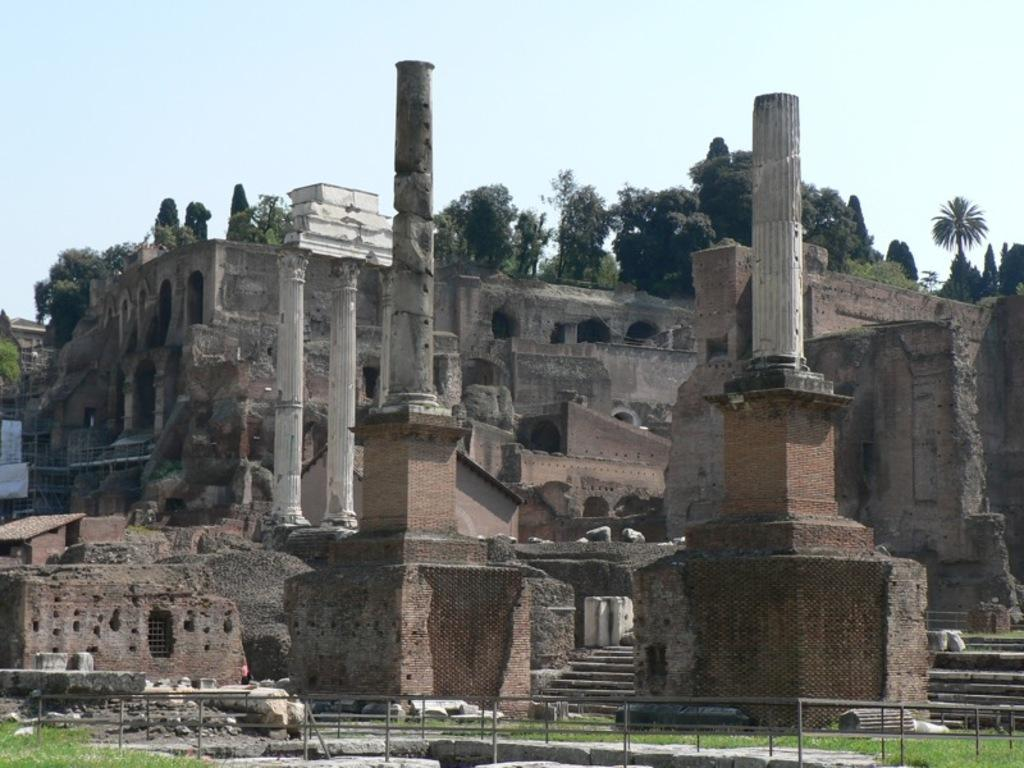What is the main subject of the image? The main subject of the image is a monument. What can be seen on the monument? There are trees on the monument. What is visible at the top of the image? The sky is visible at the top of the image. What type of voice can be heard coming from the monument in the image? There is no voice present in the image, as monuments are typically inanimate objects and do not produce sound. 